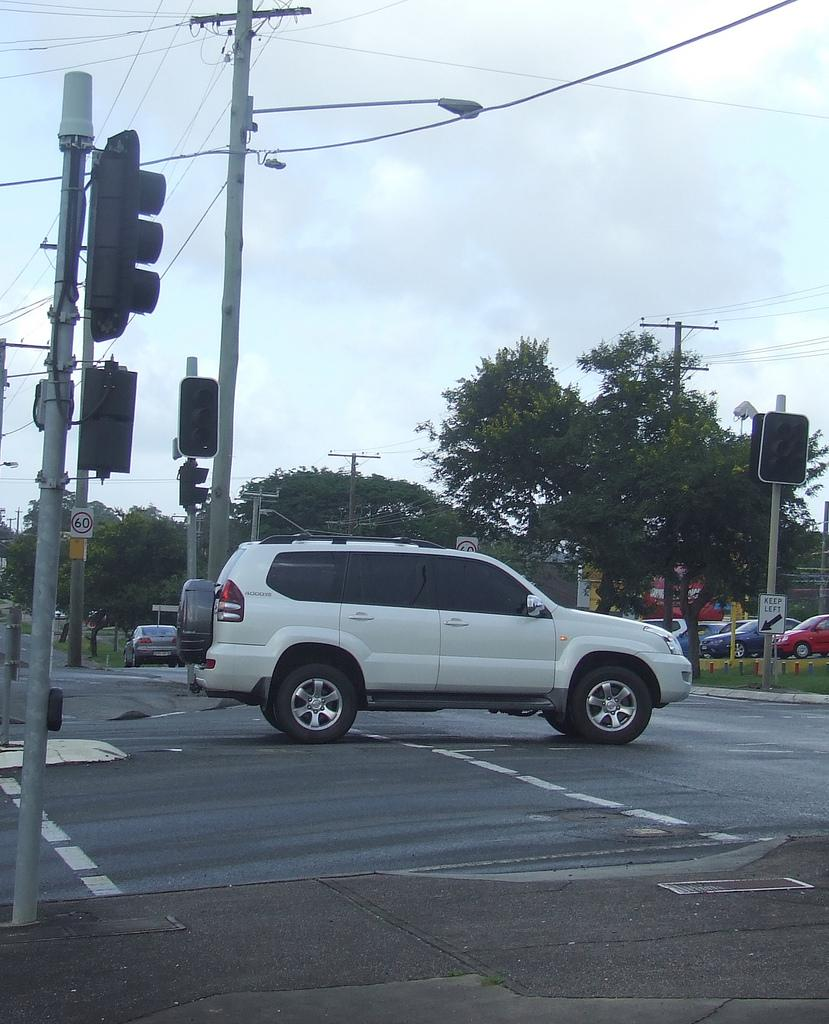Question: how fast is the car going?
Choices:
A. 90 mph.
B. Really slow.
C. Cant tell.
D. The speed limit.
Answer with the letter. Answer: C Question: what is the weather?
Choices:
A. Partly cloudy.
B. Raining.
C. Sunny.
D. Windy.
Answer with the letter. Answer: A Question: where is the next rest stop?
Choices:
A. In Lexington.
B. 8 miles.
C. In a few more miles.
D. Just over the bridge.
Answer with the letter. Answer: B Question: where are the utility poles?
Choices:
A. In the alley.
B. Behind the parking lot.
C. Beside the highway.
D. Near the street.
Answer with the letter. Answer: D Question: what kind of windows does the suv have?
Choices:
A. Tinted.
B. No windows.
C. Glass.
D. Broken.
Answer with the letter. Answer: A Question: what lights are unlit?
Choices:
A. The street lamps.
B. The chandelier.
C. The traffic lights.
D. The church lights.
Answer with the letter. Answer: C Question: what do the SUV's windows look like?
Choices:
A. They're shiny.
B. They're square.
C. They're dark.
D. They're tinted.
Answer with the letter. Answer: C Question: what directs the flow of traffic on the busy street?
Choices:
A. Policeman.
B. Lines on the road.
C. Many traffic signals.
D. Stop signs.
Answer with the letter. Answer: C Question: how many other cars are there in the turn lane?
Choices:
A. None.
B. Two.
C. Three.
D. Four.
Answer with the letter. Answer: A Question: where is the SUV?
Choices:
A. In a parking space.
B. In an intersection.
C. On the road.
D. In a parking lot.
Answer with the letter. Answer: B Question: what highway is this?
Choices:
A. 95.
B. 60.
C. 25.
D. 40.
Answer with the letter. Answer: B Question: what are the cars like?
Choices:
A. Red color.
B. Yellow color.
C. Various colors.
D. Blue color.
Answer with the letter. Answer: C Question: where is the white suv stopped?
Choices:
A. Near the intersection.
B. At a traffic light.
C. Behind the bus.
D. Outside the school.
Answer with the letter. Answer: B Question: what's on top of the SUV?
Choices:
A. A flag.
B. Luggage.
C. Dirt.
D. A rack.
Answer with the letter. Answer: D 